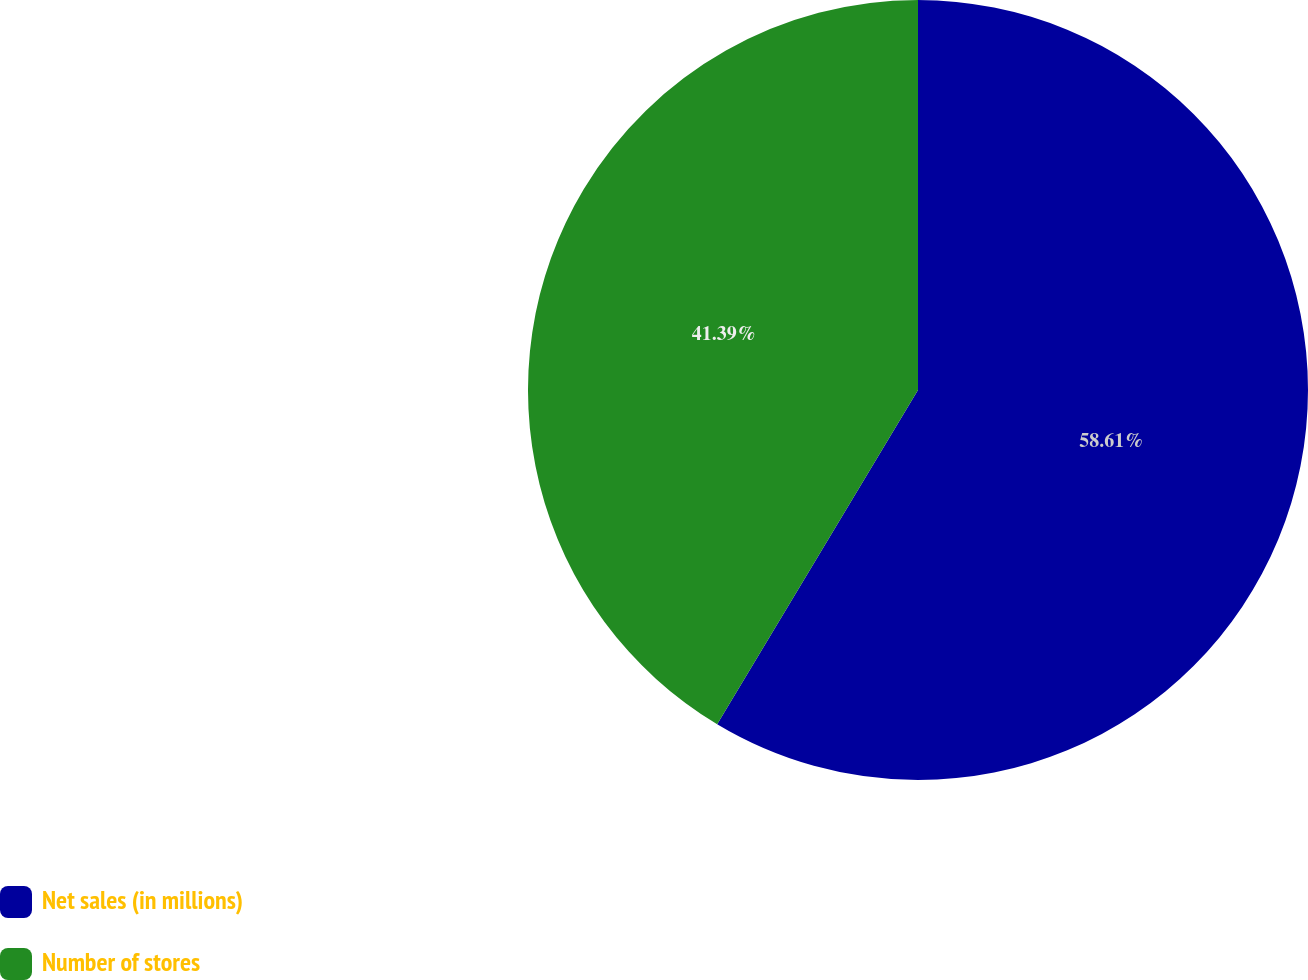<chart> <loc_0><loc_0><loc_500><loc_500><pie_chart><fcel>Net sales (in millions)<fcel>Number of stores<nl><fcel>58.61%<fcel>41.39%<nl></chart> 